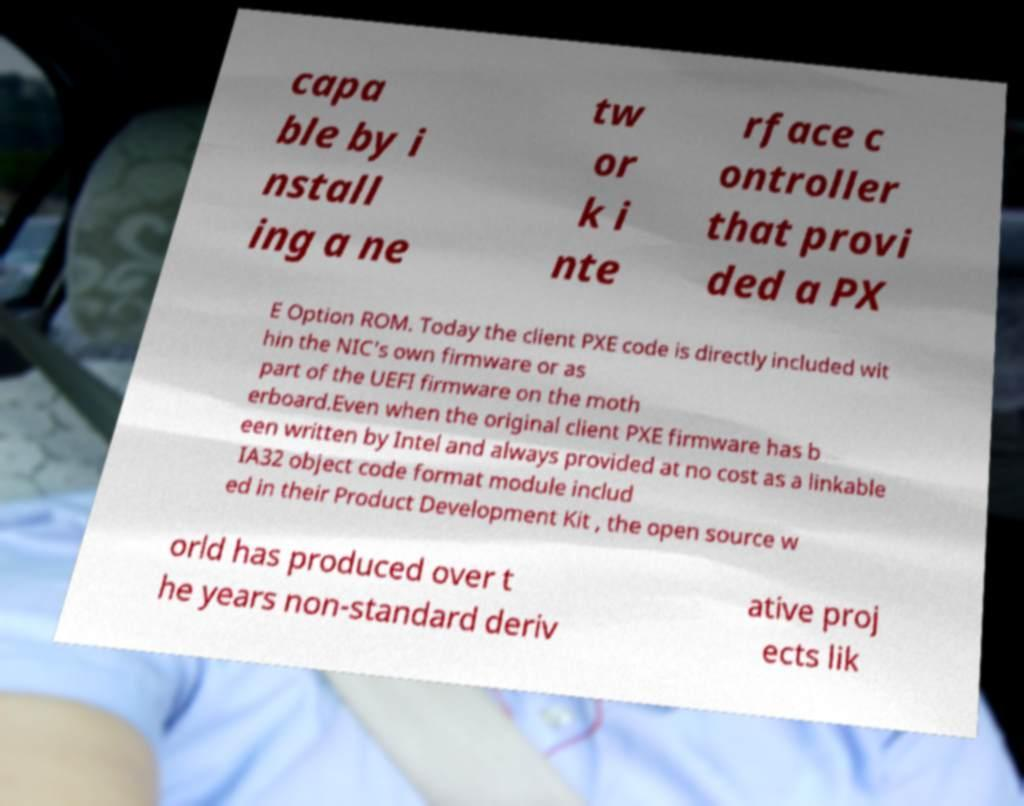Could you extract and type out the text from this image? capa ble by i nstall ing a ne tw or k i nte rface c ontroller that provi ded a PX E Option ROM. Today the client PXE code is directly included wit hin the NIC's own firmware or as part of the UEFI firmware on the moth erboard.Even when the original client PXE firmware has b een written by Intel and always provided at no cost as a linkable IA32 object code format module includ ed in their Product Development Kit , the open source w orld has produced over t he years non-standard deriv ative proj ects lik 